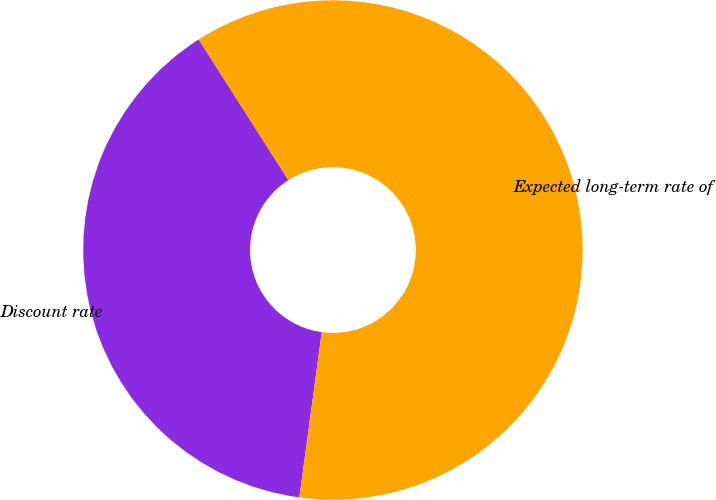<chart> <loc_0><loc_0><loc_500><loc_500><pie_chart><fcel>Discount rate<fcel>Expected long-term rate of<nl><fcel>38.82%<fcel>61.18%<nl></chart> 